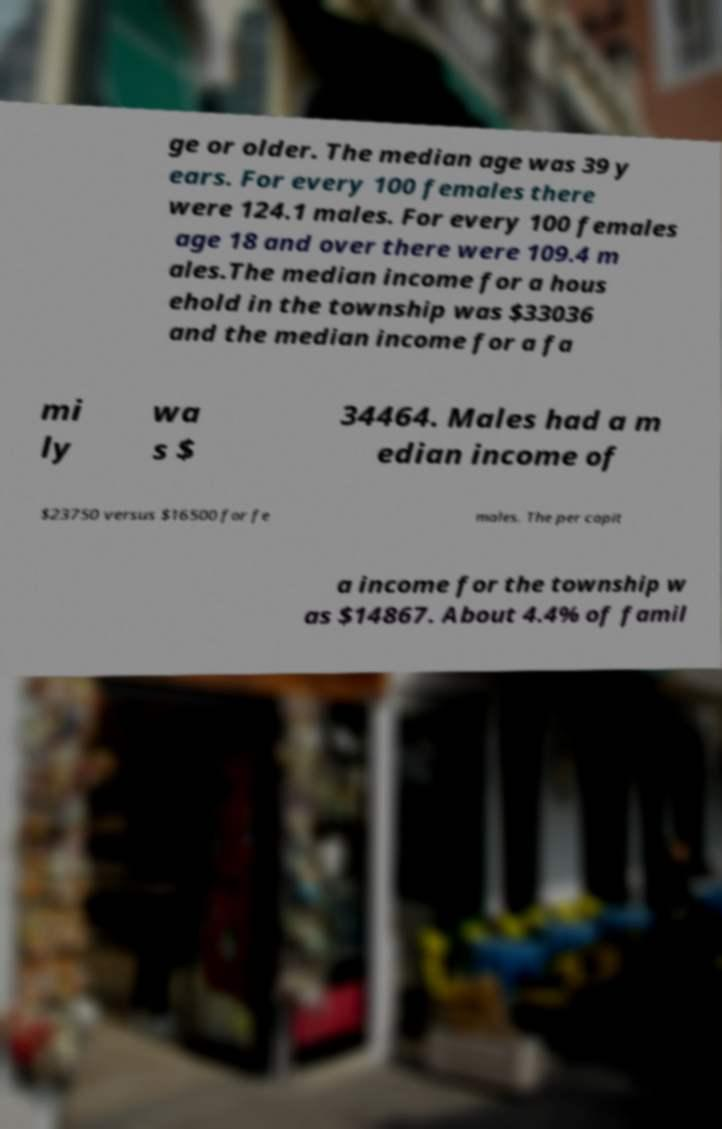Please read and relay the text visible in this image. What does it say? ge or older. The median age was 39 y ears. For every 100 females there were 124.1 males. For every 100 females age 18 and over there were 109.4 m ales.The median income for a hous ehold in the township was $33036 and the median income for a fa mi ly wa s $ 34464. Males had a m edian income of $23750 versus $16500 for fe males. The per capit a income for the township w as $14867. About 4.4% of famil 